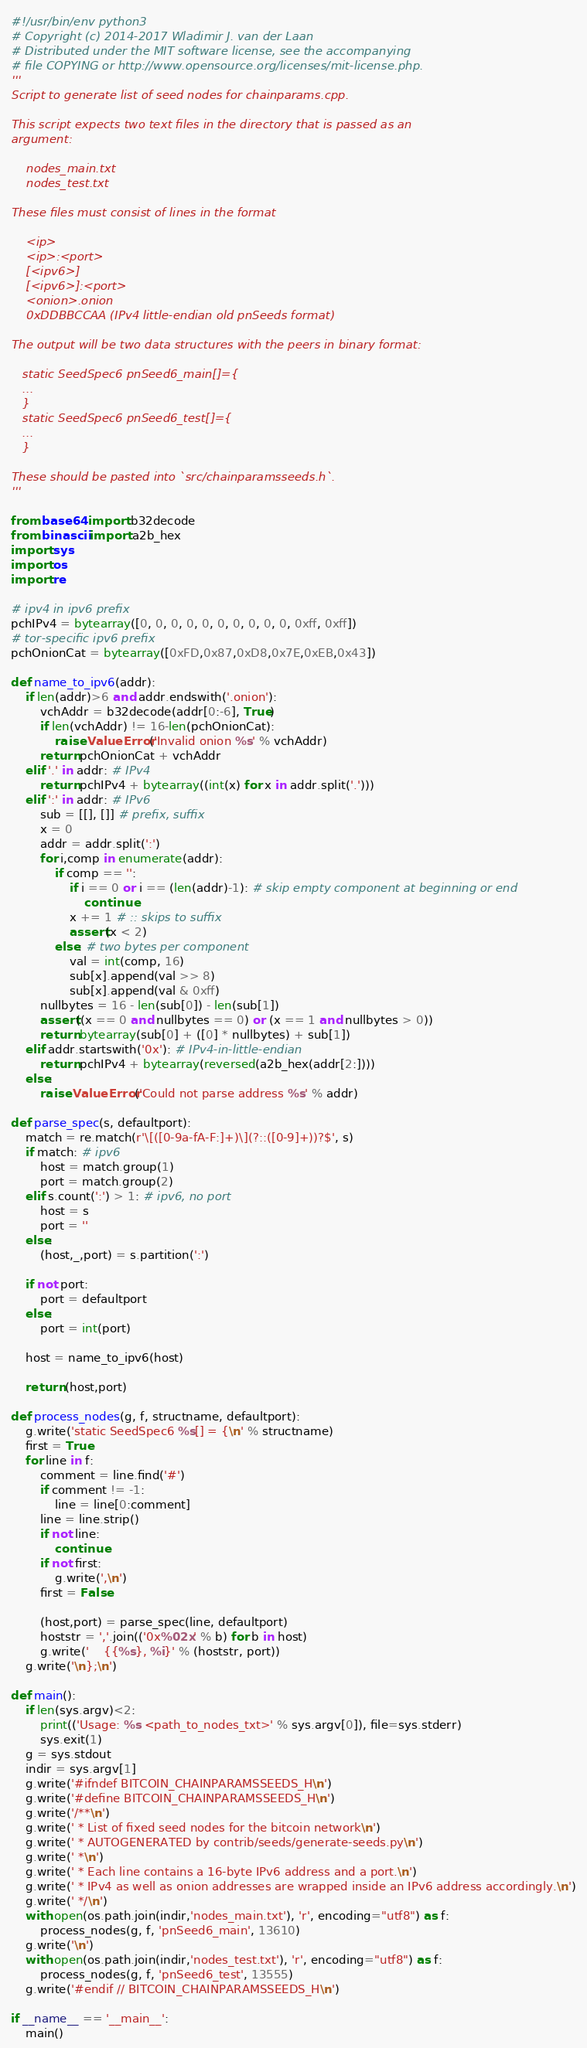Convert code to text. <code><loc_0><loc_0><loc_500><loc_500><_Python_>#!/usr/bin/env python3
# Copyright (c) 2014-2017 Wladimir J. van der Laan
# Distributed under the MIT software license, see the accompanying
# file COPYING or http://www.opensource.org/licenses/mit-license.php.
'''
Script to generate list of seed nodes for chainparams.cpp.

This script expects two text files in the directory that is passed as an
argument:

    nodes_main.txt
    nodes_test.txt

These files must consist of lines in the format

    <ip>
    <ip>:<port>
    [<ipv6>]
    [<ipv6>]:<port>
    <onion>.onion
    0xDDBBCCAA (IPv4 little-endian old pnSeeds format)

The output will be two data structures with the peers in binary format:

   static SeedSpec6 pnSeed6_main[]={
   ...
   }
   static SeedSpec6 pnSeed6_test[]={
   ...
   }

These should be pasted into `src/chainparamsseeds.h`.
'''

from base64 import b32decode
from binascii import a2b_hex
import sys
import os
import re

# ipv4 in ipv6 prefix
pchIPv4 = bytearray([0, 0, 0, 0, 0, 0, 0, 0, 0, 0, 0xff, 0xff])
# tor-specific ipv6 prefix
pchOnionCat = bytearray([0xFD,0x87,0xD8,0x7E,0xEB,0x43])

def name_to_ipv6(addr):
    if len(addr)>6 and addr.endswith('.onion'):
        vchAddr = b32decode(addr[0:-6], True)
        if len(vchAddr) != 16-len(pchOnionCat):
            raise ValueError('Invalid onion %s' % vchAddr)
        return pchOnionCat + vchAddr
    elif '.' in addr: # IPv4
        return pchIPv4 + bytearray((int(x) for x in addr.split('.')))
    elif ':' in addr: # IPv6
        sub = [[], []] # prefix, suffix
        x = 0
        addr = addr.split(':')
        for i,comp in enumerate(addr):
            if comp == '':
                if i == 0 or i == (len(addr)-1): # skip empty component at beginning or end
                    continue
                x += 1 # :: skips to suffix
                assert(x < 2)
            else: # two bytes per component
                val = int(comp, 16)
                sub[x].append(val >> 8)
                sub[x].append(val & 0xff)
        nullbytes = 16 - len(sub[0]) - len(sub[1])
        assert((x == 0 and nullbytes == 0) or (x == 1 and nullbytes > 0))
        return bytearray(sub[0] + ([0] * nullbytes) + sub[1])
    elif addr.startswith('0x'): # IPv4-in-little-endian
        return pchIPv4 + bytearray(reversed(a2b_hex(addr[2:])))
    else:
        raise ValueError('Could not parse address %s' % addr)

def parse_spec(s, defaultport):
    match = re.match(r'\[([0-9a-fA-F:]+)\](?::([0-9]+))?$', s)
    if match: # ipv6
        host = match.group(1)
        port = match.group(2)
    elif s.count(':') > 1: # ipv6, no port
        host = s
        port = ''
    else:
        (host,_,port) = s.partition(':')

    if not port:
        port = defaultport
    else:
        port = int(port)

    host = name_to_ipv6(host)

    return (host,port)

def process_nodes(g, f, structname, defaultport):
    g.write('static SeedSpec6 %s[] = {\n' % structname)
    first = True
    for line in f:
        comment = line.find('#')
        if comment != -1:
            line = line[0:comment]
        line = line.strip()
        if not line:
            continue
        if not first:
            g.write(',\n')
        first = False

        (host,port) = parse_spec(line, defaultport)
        hoststr = ','.join(('0x%02x' % b) for b in host)
        g.write('    {{%s}, %i}' % (hoststr, port))
    g.write('\n};\n')

def main():
    if len(sys.argv)<2:
        print(('Usage: %s <path_to_nodes_txt>' % sys.argv[0]), file=sys.stderr)
        sys.exit(1)
    g = sys.stdout
    indir = sys.argv[1]
    g.write('#ifndef BITCOIN_CHAINPARAMSSEEDS_H\n')
    g.write('#define BITCOIN_CHAINPARAMSSEEDS_H\n')
    g.write('/**\n')
    g.write(' * List of fixed seed nodes for the bitcoin network\n')
    g.write(' * AUTOGENERATED by contrib/seeds/generate-seeds.py\n')
    g.write(' *\n')
    g.write(' * Each line contains a 16-byte IPv6 address and a port.\n')
    g.write(' * IPv4 as well as onion addresses are wrapped inside an IPv6 address accordingly.\n')
    g.write(' */\n')
    with open(os.path.join(indir,'nodes_main.txt'), 'r', encoding="utf8") as f:
        process_nodes(g, f, 'pnSeed6_main', 13610)
    g.write('\n')
    with open(os.path.join(indir,'nodes_test.txt'), 'r', encoding="utf8") as f:
        process_nodes(g, f, 'pnSeed6_test', 13555)
    g.write('#endif // BITCOIN_CHAINPARAMSSEEDS_H\n')

if __name__ == '__main__':
    main()
</code> 